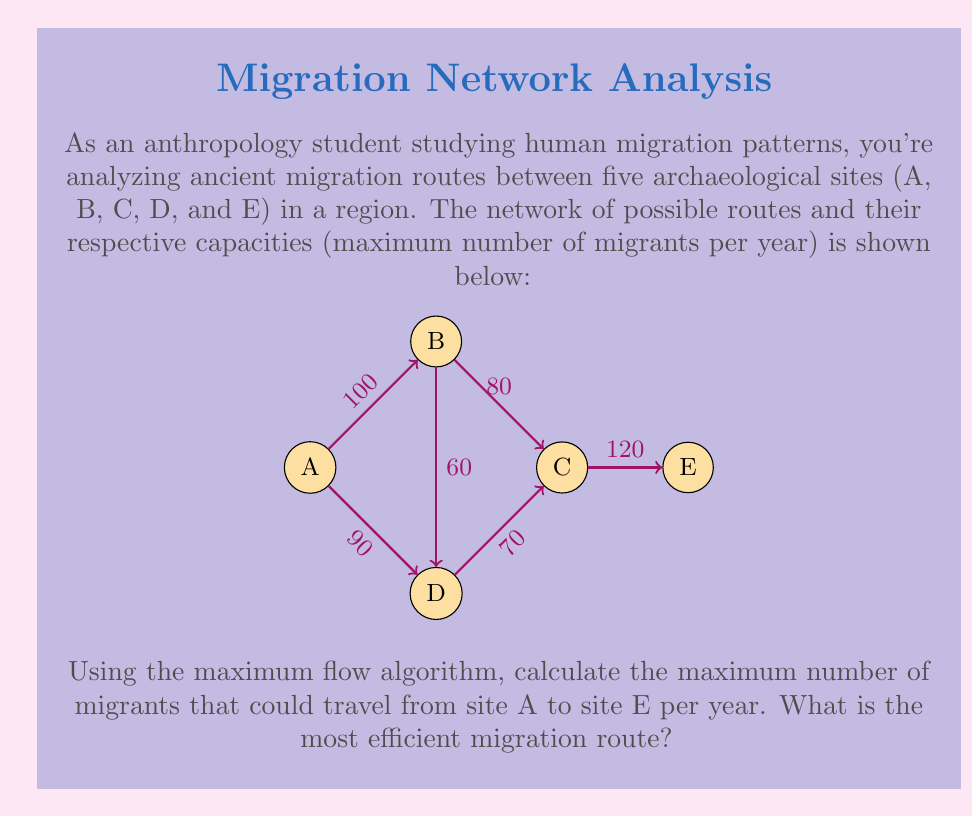Give your solution to this math problem. To solve this problem, we'll use the Ford-Fulkerson algorithm to find the maximum flow from A to E. Here's the step-by-step process:

1) Initialize the flow to 0 for all edges.

2) Find an augmenting path from A to E:
   Path 1: A → B → C → E (min capacity = 80)
   Increase flow by 80:
   A → B: 80/100
   B → C: 80/80
   C → E: 80/120

3) Find another augmenting path:
   Path 2: A → D → C → E (min capacity = 70)
   Increase flow by 70:
   A → D: 70/90
   D → C: 70/70
   C → E: 150/120 (80 + 70)

4) Find another augmenting path:
   Path 3: A → B → D → C → E (min capacity = 20)
   Increase flow by 20:
   A → B: 100/100
   B → D: 20/60
   D → C: 90/70 (70 + 20)
   C → E: 170/120 (150 + 20)

5) No more augmenting paths exist, so the maximum flow is 170.

The most efficient migration route consists of three paths:
1) A → B → C → E (80 migrants)
2) A → D → C → E (70 migrants)
3) A → B → D → C → E (20 migrants)
Answer: Maximum flow: 170 migrants per year. Most efficient route: A → B → C → E (80), A → D → C → E (70), A → B → D → C → E (20). 